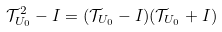<formula> <loc_0><loc_0><loc_500><loc_500>\mathcal { T } _ { U _ { 0 } } ^ { 2 } - I = ( \mathcal { T } _ { U _ { 0 } } - I ) ( \mathcal { T } _ { U _ { 0 } } + I )</formula> 